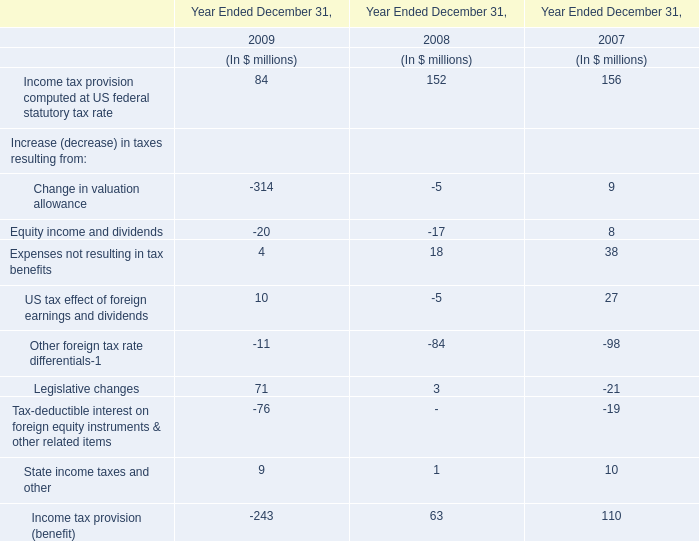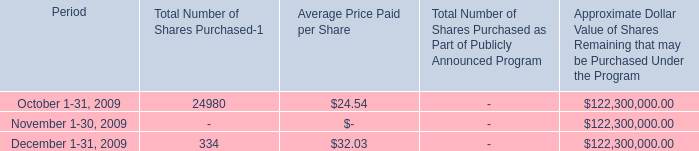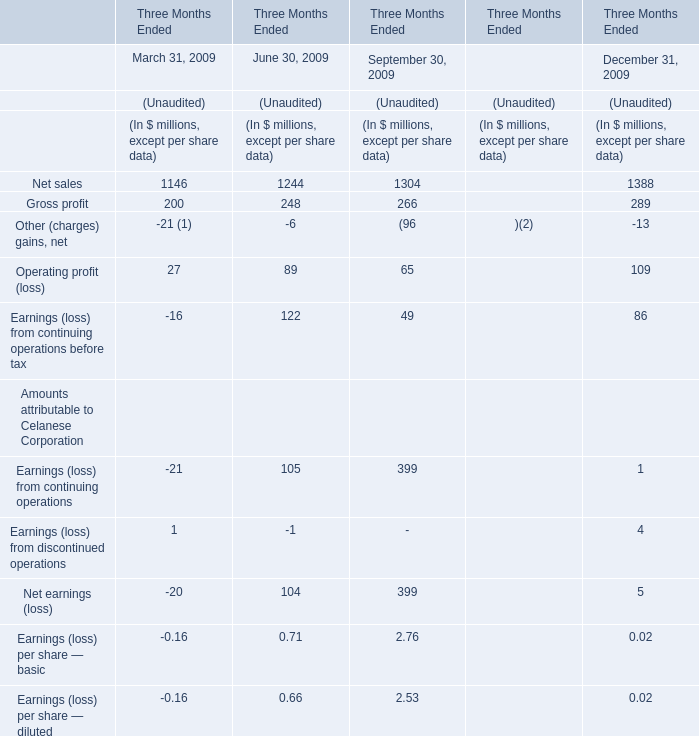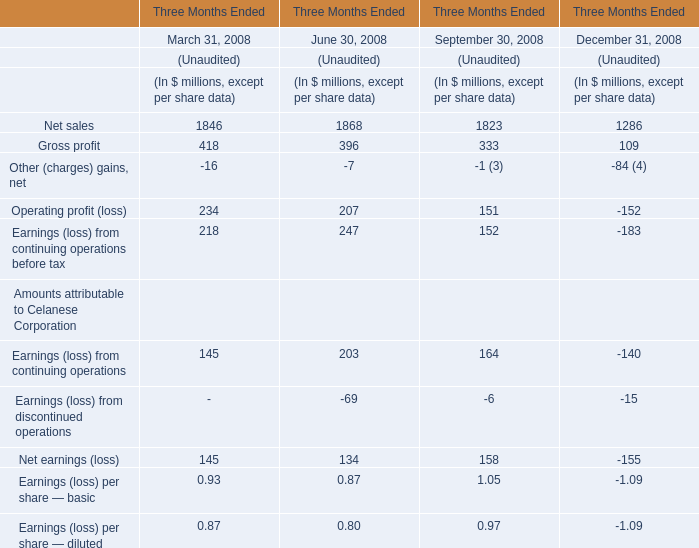In the section with lowest amount of Net sales, what's the increasing rate of Gross profit? 
Computations: ((109 - 333) / 333)
Answer: -0.67267. 